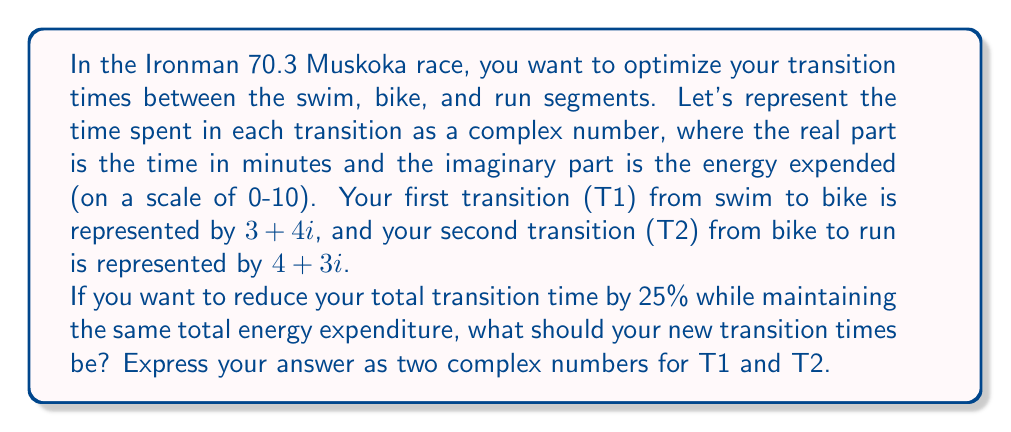Can you solve this math problem? Let's approach this step-by-step:

1) First, let's calculate the current total transition time and energy:
   
   Total = T1 + T2 = $(3 + 4i) + (4 + 3i) = 7 + 7i$

2) The real part (7) represents the total time in minutes, and the imaginary part (7) represents the total energy expended.

3) We need to reduce the time by 25% while keeping the energy the same. So our new target is:
   
   New Total = $5.25 + 7i$  (because $7 * 0.75 = 5.25$)

4) We need to find two complex numbers that add up to this new total. Let's call them $a + bi$ and $c + di$:

   $(a + bi) + (c + di) = 5.25 + 7i$

5) This gives us two equations:
   
   $a + c = 5.25$
   $b + d = 7$

6) We also want to maintain the proportion of time and energy between T1 and T2. Originally, T1 was $\frac{3}{7}$ of the time and $\frac{4}{7}$ of the energy. Let's keep this ratio:

   $a = 5.25 * \frac{3}{7} = 2.25$
   $b = 7 * \frac{4}{7} = 4$

7) We can now solve for $c$ and $d$:
   
   $c = 5.25 - a = 5.25 - 2.25 = 3$
   $d = 7 - b = 7 - 4 = 3$

Therefore, the new optimal transition times are:

T1: $2.25 + 4i$
T2: $3 + 3i$
Answer: T1: $2.25 + 4i$, T2: $3 + 3i$ 